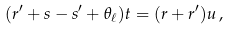Convert formula to latex. <formula><loc_0><loc_0><loc_500><loc_500>( r ^ { \prime } + s - s ^ { \prime } + \theta _ { \ell } ) t = ( r + r ^ { \prime } ) u \, ,</formula> 